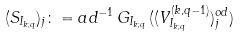<formula> <loc_0><loc_0><loc_500><loc_500>( S _ { I _ { k ; q } } ) _ { j } \colon = a d ^ { - 1 } \, G _ { I _ { k ; q } } \, ( ( V ^ { ( k , q - 1 ) } _ { I _ { k ; q } } ) ^ { o d } _ { j } ) \,</formula> 